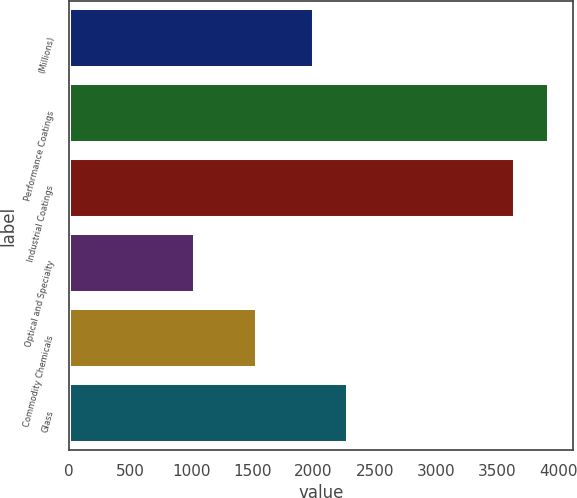<chart> <loc_0><loc_0><loc_500><loc_500><bar_chart><fcel>(Millions)<fcel>Performance Coatings<fcel>Industrial Coatings<fcel>Optical and Specialty<fcel>Commodity Chemicals<fcel>Glass<nl><fcel>2007<fcel>3924.2<fcel>3646<fcel>1029<fcel>1539<fcel>2285.2<nl></chart> 